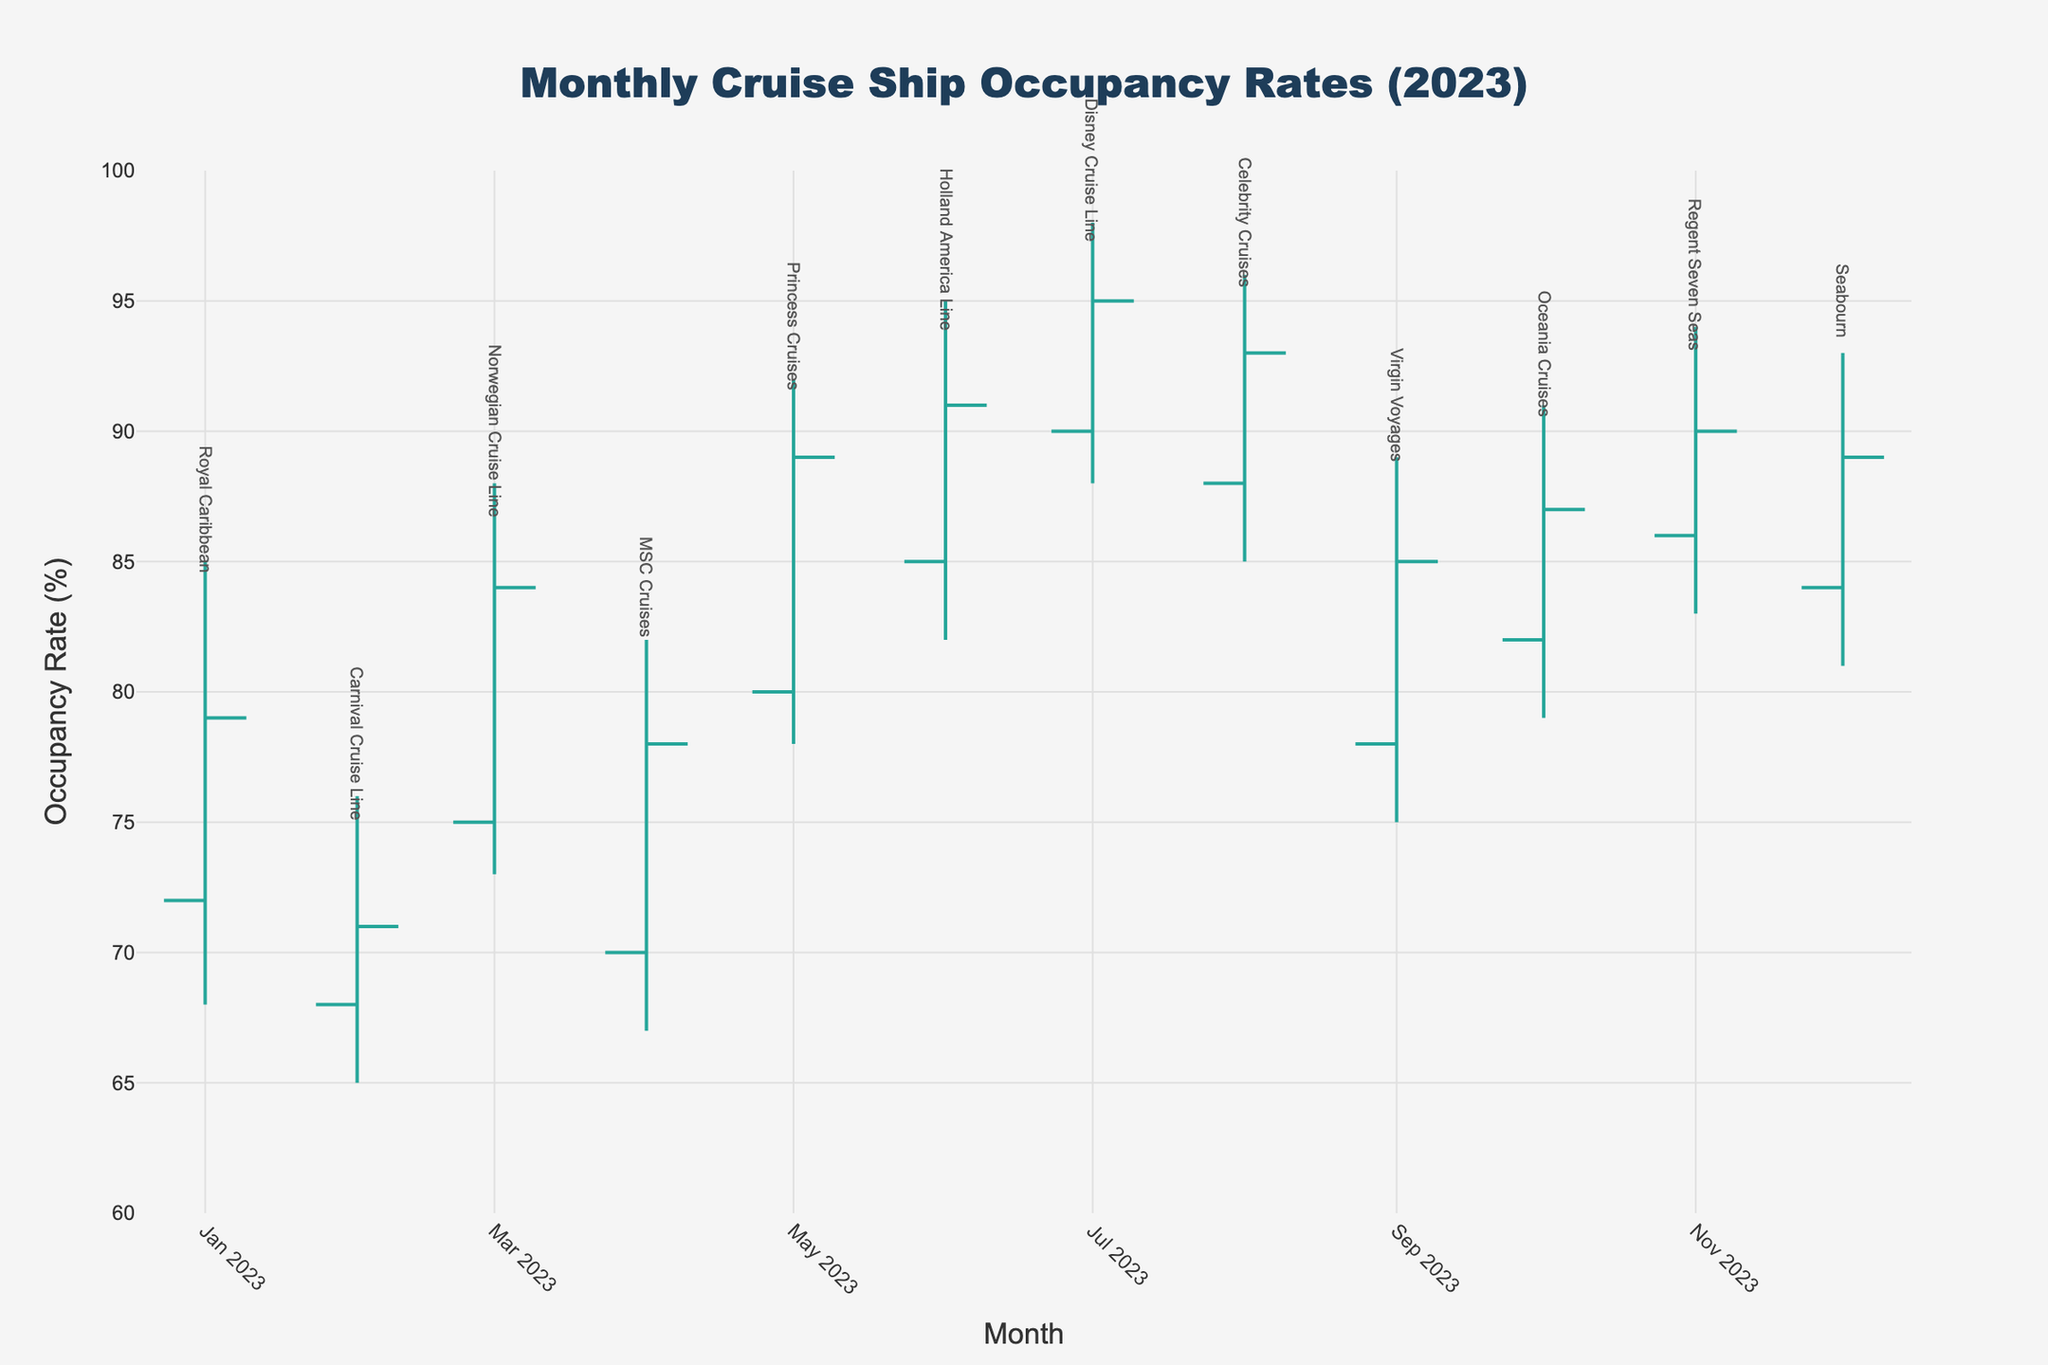What's the title of the figure? The title is usually placed at the top of the figure and is used to describe the subject of the data being visualized. In this case, the title reads "Monthly Cruise Ship Occupancy Rates (2023)."
Answer: Monthly Cruise Ship Occupancy Rates (2023) How many cruise lines are represented in the figure? The annotations in the figure show the names of each cruise line, and you can count them to determine the number of different cruise lines.
Answer: 12 Which month had the highest occupancy rate for any cruise line, and what was the occupancy rate? By looking at the highs for each month, the highest occupancy rate can be identified. July had the highest rate, with Disney Cruise Line reaching an occupancy rate of 98%.
Answer: July, 98% Which cruise line had the lowest closing occupancy rate, and what was the rate? Closing rates are listed in the last column. By comparing these values, Carnival Cruise Line had the lowest closing rate with 71% in February.
Answer: Carnival Cruise Line, 71% Between which months was the largest increase in the closing occupancy rate, and by how much did it increase? Check the closing values for consecutive months and find the largest difference. March to April saw an increase from 84% (Norwegian Cruise Line) to 89% (Princess Cruises), an increase of 5 percentage points.
Answer: March to April, 5% Which month had the smallest range between the high and low occupancy rates, and what was the range? The range can be calculated by subtracting the low from the high for each month. August had the smallest range, with a high of 96% and a low of 85%, making the range 11%.
Answer: August, 11% Identify the months where the closing occupancy rate was higher than the opening rate and name the cruise lines. Compare the opening and closing occupancy rates for each month. For January (Royal Caribbean), March (Norwegian), April (MSC Cruises), May (Princess Cruises), June (Holland America Line), July (Disney), August (Celebrity), September (Virgin Voyages), October (Oceania), and November (Regent Seven Seas), the closing rate was higher than the opening rate.
Answer: January (Royal Caribbean), March (Norwegian), April (MSC), May (Princess), June (Holland America), July (Disney), August (Celebrity), September (Virgin), October (Oceania), November (Regent Seven Seas) Which cruise line showed the highest variability in occupancy within a single month, and what is the range of that variability? The variability within a month can be seen by the difference between the high and low values. Norwegian Cruise Line in March had the highest variability with a range of 15% (88% - 73%).
Answer: Norwegian Cruise Line, 15% What was the closing occupancy rate for MSC Cruises in April? Look at the closing rate for MSC Cruises in April, which is listed under the "Close" column for that month.
Answer: 78% Which cruise line managed to close each month at 89% occupancy rate, and across how many months did this occur? Reviewing the closing occupancy rates, Princess Cruises in May and Seabourn in December both closed at 89%. Therefore, two months had this closing rate.
Answer: Princess Cruises and Seabourn, 2 